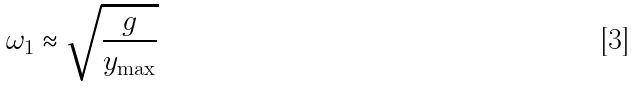<formula> <loc_0><loc_0><loc_500><loc_500>\omega _ { 1 } \approx \sqrt { \frac { g } { y _ { \max } } }</formula> 